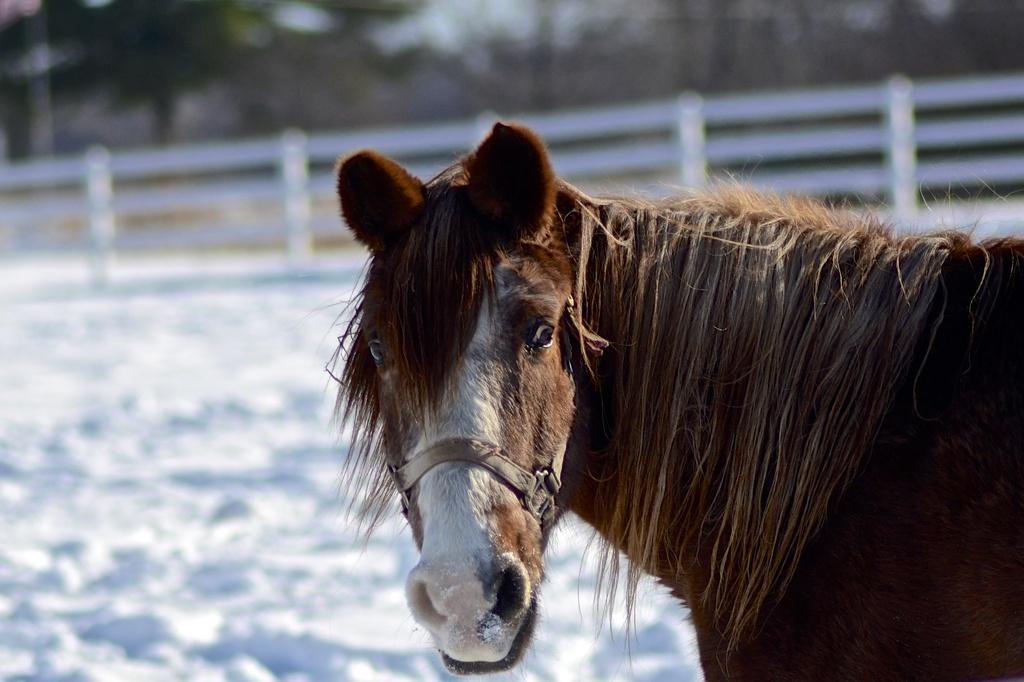In one or two sentences, can you explain what this image depicts? On the right side, there is a brown color horse standing on the snow surface. In the background, there is white color fencing, there are trees and there is sky. 